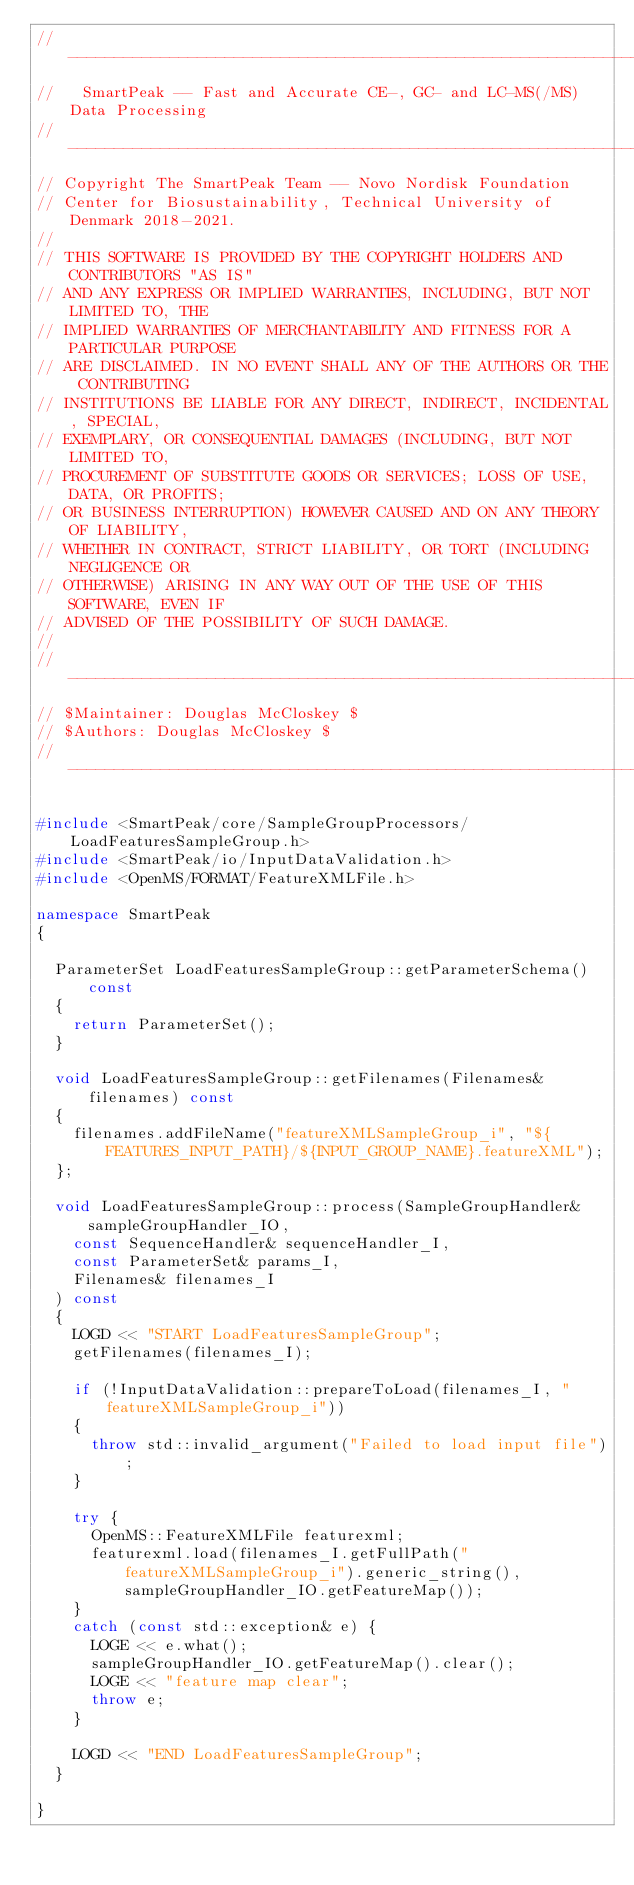<code> <loc_0><loc_0><loc_500><loc_500><_C++_>// --------------------------------------------------------------------------
//   SmartPeak -- Fast and Accurate CE-, GC- and LC-MS(/MS) Data Processing
// --------------------------------------------------------------------------
// Copyright The SmartPeak Team -- Novo Nordisk Foundation 
// Center for Biosustainability, Technical University of Denmark 2018-2021.
//
// THIS SOFTWARE IS PROVIDED BY THE COPYRIGHT HOLDERS AND CONTRIBUTORS "AS IS"
// AND ANY EXPRESS OR IMPLIED WARRANTIES, INCLUDING, BUT NOT LIMITED TO, THE
// IMPLIED WARRANTIES OF MERCHANTABILITY AND FITNESS FOR A PARTICULAR PURPOSE
// ARE DISCLAIMED. IN NO EVENT SHALL ANY OF THE AUTHORS OR THE CONTRIBUTING
// INSTITUTIONS BE LIABLE FOR ANY DIRECT, INDIRECT, INCIDENTAL, SPECIAL,
// EXEMPLARY, OR CONSEQUENTIAL DAMAGES (INCLUDING, BUT NOT LIMITED TO,
// PROCUREMENT OF SUBSTITUTE GOODS OR SERVICES; LOSS OF USE, DATA, OR PROFITS;
// OR BUSINESS INTERRUPTION) HOWEVER CAUSED AND ON ANY THEORY OF LIABILITY,
// WHETHER IN CONTRACT, STRICT LIABILITY, OR TORT (INCLUDING NEGLIGENCE OR
// OTHERWISE) ARISING IN ANY WAY OUT OF THE USE OF THIS SOFTWARE, EVEN IF
// ADVISED OF THE POSSIBILITY OF SUCH DAMAGE.
//
// --------------------------------------------------------------------------
// $Maintainer: Douglas McCloskey $
// $Authors: Douglas McCloskey $
// --------------------------------------------------------------------------

#include <SmartPeak/core/SampleGroupProcessors/LoadFeaturesSampleGroup.h>
#include <SmartPeak/io/InputDataValidation.h>
#include <OpenMS/FORMAT/FeatureXMLFile.h>

namespace SmartPeak
{

  ParameterSet LoadFeaturesSampleGroup::getParameterSchema() const
  {
    return ParameterSet();
  }

  void LoadFeaturesSampleGroup::getFilenames(Filenames& filenames) const
  {
    filenames.addFileName("featureXMLSampleGroup_i", "${FEATURES_INPUT_PATH}/${INPUT_GROUP_NAME}.featureXML");
  };

  void LoadFeaturesSampleGroup::process(SampleGroupHandler& sampleGroupHandler_IO,
    const SequenceHandler& sequenceHandler_I,
    const ParameterSet& params_I,
    Filenames& filenames_I
  ) const
  {
    LOGD << "START LoadFeaturesSampleGroup";
    getFilenames(filenames_I);

    if (!InputDataValidation::prepareToLoad(filenames_I, "featureXMLSampleGroup_i"))
    {
      throw std::invalid_argument("Failed to load input file");
    }

    try {
      OpenMS::FeatureXMLFile featurexml;
      featurexml.load(filenames_I.getFullPath("featureXMLSampleGroup_i").generic_string(), sampleGroupHandler_IO.getFeatureMap());
    }
    catch (const std::exception& e) {
      LOGE << e.what();
      sampleGroupHandler_IO.getFeatureMap().clear();
      LOGE << "feature map clear";
      throw e;
    }

    LOGD << "END LoadFeaturesSampleGroup";
  }

}
</code> 